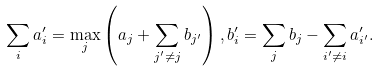Convert formula to latex. <formula><loc_0><loc_0><loc_500><loc_500>\sum _ { i } a _ { i } ^ { \prime } = \max _ { j } \left ( a _ { j } + \sum _ { j ^ { \prime } \neq j } b _ { j ^ { \prime } } \right ) , b _ { i } ^ { \prime } = \sum _ { j } b _ { j } - \sum _ { i ^ { \prime } \neq i } a _ { i ^ { \prime } } ^ { \prime } .</formula> 